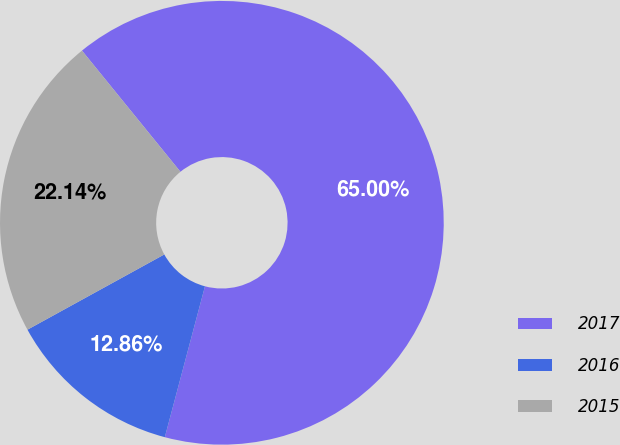<chart> <loc_0><loc_0><loc_500><loc_500><pie_chart><fcel>2017<fcel>2016<fcel>2015<nl><fcel>65.0%<fcel>12.86%<fcel>22.14%<nl></chart> 